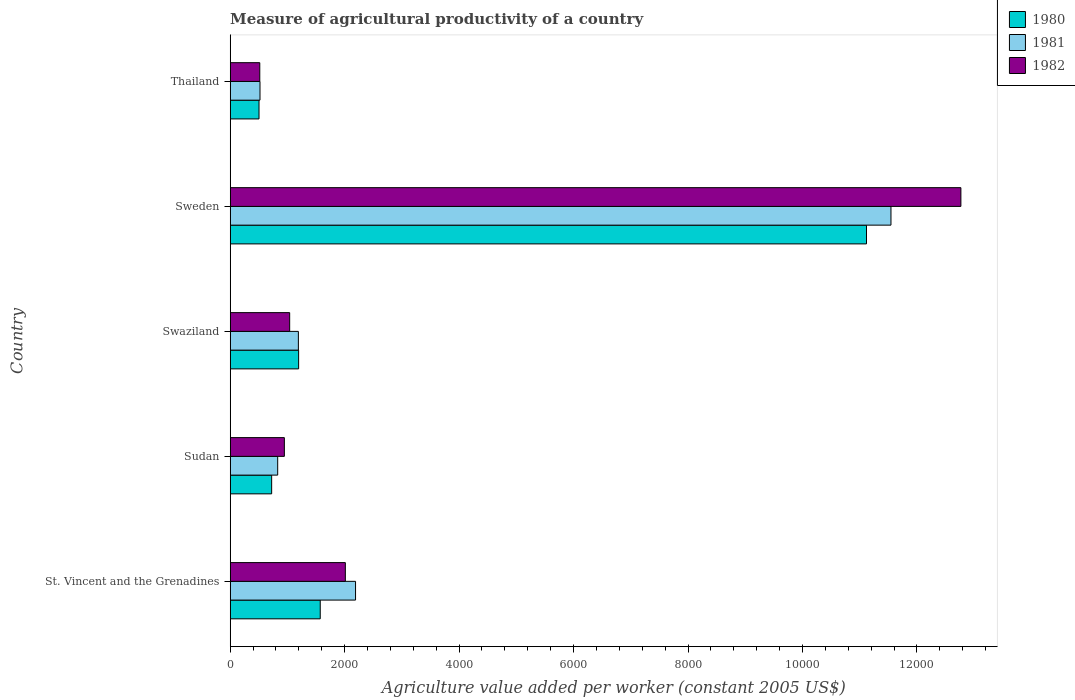How many different coloured bars are there?
Make the answer very short. 3. How many groups of bars are there?
Give a very brief answer. 5. How many bars are there on the 2nd tick from the bottom?
Keep it short and to the point. 3. What is the label of the 1st group of bars from the top?
Provide a succinct answer. Thailand. What is the measure of agricultural productivity in 1982 in Sweden?
Offer a very short reply. 1.28e+04. Across all countries, what is the maximum measure of agricultural productivity in 1980?
Provide a succinct answer. 1.11e+04. Across all countries, what is the minimum measure of agricultural productivity in 1981?
Ensure brevity in your answer.  521.09. In which country was the measure of agricultural productivity in 1981 maximum?
Keep it short and to the point. Sweden. In which country was the measure of agricultural productivity in 1982 minimum?
Your response must be concise. Thailand. What is the total measure of agricultural productivity in 1981 in the graph?
Make the answer very short. 1.63e+04. What is the difference between the measure of agricultural productivity in 1980 in St. Vincent and the Grenadines and that in Sweden?
Ensure brevity in your answer.  -9545.66. What is the difference between the measure of agricultural productivity in 1981 in Sweden and the measure of agricultural productivity in 1982 in Swaziland?
Keep it short and to the point. 1.05e+04. What is the average measure of agricultural productivity in 1981 per country?
Make the answer very short. 3255.98. What is the difference between the measure of agricultural productivity in 1980 and measure of agricultural productivity in 1981 in Thailand?
Make the answer very short. -17.34. What is the ratio of the measure of agricultural productivity in 1982 in Sweden to that in Thailand?
Ensure brevity in your answer.  24.69. Is the measure of agricultural productivity in 1980 in St. Vincent and the Grenadines less than that in Thailand?
Provide a short and direct response. No. What is the difference between the highest and the second highest measure of agricultural productivity in 1982?
Your answer should be compact. 1.08e+04. What is the difference between the highest and the lowest measure of agricultural productivity in 1980?
Your answer should be very brief. 1.06e+04. What does the 1st bar from the top in Swaziland represents?
Provide a short and direct response. 1982. What does the 2nd bar from the bottom in Thailand represents?
Make the answer very short. 1981. How many bars are there?
Offer a very short reply. 15. How many countries are there in the graph?
Provide a short and direct response. 5. Are the values on the major ticks of X-axis written in scientific E-notation?
Offer a terse response. No. Does the graph contain any zero values?
Ensure brevity in your answer.  No. What is the title of the graph?
Provide a short and direct response. Measure of agricultural productivity of a country. What is the label or title of the X-axis?
Provide a succinct answer. Agriculture value added per worker (constant 2005 US$). What is the label or title of the Y-axis?
Provide a succinct answer. Country. What is the Agriculture value added per worker (constant 2005 US$) in 1980 in St. Vincent and the Grenadines?
Your answer should be compact. 1573.39. What is the Agriculture value added per worker (constant 2005 US$) in 1981 in St. Vincent and the Grenadines?
Keep it short and to the point. 2190.63. What is the Agriculture value added per worker (constant 2005 US$) in 1982 in St. Vincent and the Grenadines?
Make the answer very short. 2012.15. What is the Agriculture value added per worker (constant 2005 US$) in 1980 in Sudan?
Keep it short and to the point. 724.57. What is the Agriculture value added per worker (constant 2005 US$) of 1981 in Sudan?
Offer a terse response. 829.99. What is the Agriculture value added per worker (constant 2005 US$) in 1982 in Sudan?
Make the answer very short. 946.58. What is the Agriculture value added per worker (constant 2005 US$) of 1980 in Swaziland?
Keep it short and to the point. 1196. What is the Agriculture value added per worker (constant 2005 US$) in 1981 in Swaziland?
Your answer should be very brief. 1191.63. What is the Agriculture value added per worker (constant 2005 US$) of 1982 in Swaziland?
Your response must be concise. 1039.39. What is the Agriculture value added per worker (constant 2005 US$) in 1980 in Sweden?
Your response must be concise. 1.11e+04. What is the Agriculture value added per worker (constant 2005 US$) of 1981 in Sweden?
Provide a succinct answer. 1.15e+04. What is the Agriculture value added per worker (constant 2005 US$) in 1982 in Sweden?
Offer a terse response. 1.28e+04. What is the Agriculture value added per worker (constant 2005 US$) of 1980 in Thailand?
Offer a terse response. 503.75. What is the Agriculture value added per worker (constant 2005 US$) of 1981 in Thailand?
Ensure brevity in your answer.  521.09. What is the Agriculture value added per worker (constant 2005 US$) in 1982 in Thailand?
Provide a short and direct response. 517.06. Across all countries, what is the maximum Agriculture value added per worker (constant 2005 US$) in 1980?
Your response must be concise. 1.11e+04. Across all countries, what is the maximum Agriculture value added per worker (constant 2005 US$) of 1981?
Your answer should be compact. 1.15e+04. Across all countries, what is the maximum Agriculture value added per worker (constant 2005 US$) in 1982?
Give a very brief answer. 1.28e+04. Across all countries, what is the minimum Agriculture value added per worker (constant 2005 US$) of 1980?
Offer a terse response. 503.75. Across all countries, what is the minimum Agriculture value added per worker (constant 2005 US$) of 1981?
Give a very brief answer. 521.09. Across all countries, what is the minimum Agriculture value added per worker (constant 2005 US$) in 1982?
Provide a succinct answer. 517.06. What is the total Agriculture value added per worker (constant 2005 US$) in 1980 in the graph?
Ensure brevity in your answer.  1.51e+04. What is the total Agriculture value added per worker (constant 2005 US$) of 1981 in the graph?
Ensure brevity in your answer.  1.63e+04. What is the total Agriculture value added per worker (constant 2005 US$) in 1982 in the graph?
Provide a short and direct response. 1.73e+04. What is the difference between the Agriculture value added per worker (constant 2005 US$) in 1980 in St. Vincent and the Grenadines and that in Sudan?
Your answer should be compact. 848.82. What is the difference between the Agriculture value added per worker (constant 2005 US$) of 1981 in St. Vincent and the Grenadines and that in Sudan?
Ensure brevity in your answer.  1360.64. What is the difference between the Agriculture value added per worker (constant 2005 US$) in 1982 in St. Vincent and the Grenadines and that in Sudan?
Give a very brief answer. 1065.58. What is the difference between the Agriculture value added per worker (constant 2005 US$) in 1980 in St. Vincent and the Grenadines and that in Swaziland?
Provide a succinct answer. 377.39. What is the difference between the Agriculture value added per worker (constant 2005 US$) in 1981 in St. Vincent and the Grenadines and that in Swaziland?
Your response must be concise. 999. What is the difference between the Agriculture value added per worker (constant 2005 US$) in 1982 in St. Vincent and the Grenadines and that in Swaziland?
Ensure brevity in your answer.  972.77. What is the difference between the Agriculture value added per worker (constant 2005 US$) in 1980 in St. Vincent and the Grenadines and that in Sweden?
Offer a terse response. -9545.66. What is the difference between the Agriculture value added per worker (constant 2005 US$) of 1981 in St. Vincent and the Grenadines and that in Sweden?
Offer a very short reply. -9355.93. What is the difference between the Agriculture value added per worker (constant 2005 US$) in 1982 in St. Vincent and the Grenadines and that in Sweden?
Keep it short and to the point. -1.08e+04. What is the difference between the Agriculture value added per worker (constant 2005 US$) of 1980 in St. Vincent and the Grenadines and that in Thailand?
Your answer should be compact. 1069.64. What is the difference between the Agriculture value added per worker (constant 2005 US$) of 1981 in St. Vincent and the Grenadines and that in Thailand?
Ensure brevity in your answer.  1669.53. What is the difference between the Agriculture value added per worker (constant 2005 US$) in 1982 in St. Vincent and the Grenadines and that in Thailand?
Provide a short and direct response. 1495.1. What is the difference between the Agriculture value added per worker (constant 2005 US$) of 1980 in Sudan and that in Swaziland?
Keep it short and to the point. -471.43. What is the difference between the Agriculture value added per worker (constant 2005 US$) in 1981 in Sudan and that in Swaziland?
Your response must be concise. -361.64. What is the difference between the Agriculture value added per worker (constant 2005 US$) in 1982 in Sudan and that in Swaziland?
Your response must be concise. -92.81. What is the difference between the Agriculture value added per worker (constant 2005 US$) of 1980 in Sudan and that in Sweden?
Keep it short and to the point. -1.04e+04. What is the difference between the Agriculture value added per worker (constant 2005 US$) of 1981 in Sudan and that in Sweden?
Make the answer very short. -1.07e+04. What is the difference between the Agriculture value added per worker (constant 2005 US$) in 1982 in Sudan and that in Sweden?
Your answer should be very brief. -1.18e+04. What is the difference between the Agriculture value added per worker (constant 2005 US$) of 1980 in Sudan and that in Thailand?
Your answer should be compact. 220.82. What is the difference between the Agriculture value added per worker (constant 2005 US$) in 1981 in Sudan and that in Thailand?
Provide a succinct answer. 308.9. What is the difference between the Agriculture value added per worker (constant 2005 US$) in 1982 in Sudan and that in Thailand?
Offer a terse response. 429.52. What is the difference between the Agriculture value added per worker (constant 2005 US$) of 1980 in Swaziland and that in Sweden?
Your answer should be very brief. -9923.05. What is the difference between the Agriculture value added per worker (constant 2005 US$) in 1981 in Swaziland and that in Sweden?
Ensure brevity in your answer.  -1.04e+04. What is the difference between the Agriculture value added per worker (constant 2005 US$) in 1982 in Swaziland and that in Sweden?
Your answer should be compact. -1.17e+04. What is the difference between the Agriculture value added per worker (constant 2005 US$) of 1980 in Swaziland and that in Thailand?
Ensure brevity in your answer.  692.25. What is the difference between the Agriculture value added per worker (constant 2005 US$) in 1981 in Swaziland and that in Thailand?
Provide a short and direct response. 670.54. What is the difference between the Agriculture value added per worker (constant 2005 US$) of 1982 in Swaziland and that in Thailand?
Provide a short and direct response. 522.33. What is the difference between the Agriculture value added per worker (constant 2005 US$) of 1980 in Sweden and that in Thailand?
Make the answer very short. 1.06e+04. What is the difference between the Agriculture value added per worker (constant 2005 US$) of 1981 in Sweden and that in Thailand?
Keep it short and to the point. 1.10e+04. What is the difference between the Agriculture value added per worker (constant 2005 US$) of 1982 in Sweden and that in Thailand?
Your answer should be very brief. 1.23e+04. What is the difference between the Agriculture value added per worker (constant 2005 US$) of 1980 in St. Vincent and the Grenadines and the Agriculture value added per worker (constant 2005 US$) of 1981 in Sudan?
Offer a very short reply. 743.4. What is the difference between the Agriculture value added per worker (constant 2005 US$) in 1980 in St. Vincent and the Grenadines and the Agriculture value added per worker (constant 2005 US$) in 1982 in Sudan?
Provide a succinct answer. 626.81. What is the difference between the Agriculture value added per worker (constant 2005 US$) of 1981 in St. Vincent and the Grenadines and the Agriculture value added per worker (constant 2005 US$) of 1982 in Sudan?
Provide a short and direct response. 1244.05. What is the difference between the Agriculture value added per worker (constant 2005 US$) in 1980 in St. Vincent and the Grenadines and the Agriculture value added per worker (constant 2005 US$) in 1981 in Swaziland?
Give a very brief answer. 381.76. What is the difference between the Agriculture value added per worker (constant 2005 US$) of 1980 in St. Vincent and the Grenadines and the Agriculture value added per worker (constant 2005 US$) of 1982 in Swaziland?
Your answer should be compact. 534. What is the difference between the Agriculture value added per worker (constant 2005 US$) of 1981 in St. Vincent and the Grenadines and the Agriculture value added per worker (constant 2005 US$) of 1982 in Swaziland?
Your answer should be compact. 1151.24. What is the difference between the Agriculture value added per worker (constant 2005 US$) of 1980 in St. Vincent and the Grenadines and the Agriculture value added per worker (constant 2005 US$) of 1981 in Sweden?
Give a very brief answer. -9973.17. What is the difference between the Agriculture value added per worker (constant 2005 US$) of 1980 in St. Vincent and the Grenadines and the Agriculture value added per worker (constant 2005 US$) of 1982 in Sweden?
Ensure brevity in your answer.  -1.12e+04. What is the difference between the Agriculture value added per worker (constant 2005 US$) in 1981 in St. Vincent and the Grenadines and the Agriculture value added per worker (constant 2005 US$) in 1982 in Sweden?
Your answer should be compact. -1.06e+04. What is the difference between the Agriculture value added per worker (constant 2005 US$) of 1980 in St. Vincent and the Grenadines and the Agriculture value added per worker (constant 2005 US$) of 1981 in Thailand?
Ensure brevity in your answer.  1052.3. What is the difference between the Agriculture value added per worker (constant 2005 US$) of 1980 in St. Vincent and the Grenadines and the Agriculture value added per worker (constant 2005 US$) of 1982 in Thailand?
Provide a short and direct response. 1056.33. What is the difference between the Agriculture value added per worker (constant 2005 US$) of 1981 in St. Vincent and the Grenadines and the Agriculture value added per worker (constant 2005 US$) of 1982 in Thailand?
Your answer should be very brief. 1673.57. What is the difference between the Agriculture value added per worker (constant 2005 US$) in 1980 in Sudan and the Agriculture value added per worker (constant 2005 US$) in 1981 in Swaziland?
Offer a very short reply. -467.06. What is the difference between the Agriculture value added per worker (constant 2005 US$) in 1980 in Sudan and the Agriculture value added per worker (constant 2005 US$) in 1982 in Swaziland?
Your answer should be very brief. -314.82. What is the difference between the Agriculture value added per worker (constant 2005 US$) of 1981 in Sudan and the Agriculture value added per worker (constant 2005 US$) of 1982 in Swaziland?
Your answer should be very brief. -209.4. What is the difference between the Agriculture value added per worker (constant 2005 US$) in 1980 in Sudan and the Agriculture value added per worker (constant 2005 US$) in 1981 in Sweden?
Ensure brevity in your answer.  -1.08e+04. What is the difference between the Agriculture value added per worker (constant 2005 US$) of 1980 in Sudan and the Agriculture value added per worker (constant 2005 US$) of 1982 in Sweden?
Provide a succinct answer. -1.20e+04. What is the difference between the Agriculture value added per worker (constant 2005 US$) in 1981 in Sudan and the Agriculture value added per worker (constant 2005 US$) in 1982 in Sweden?
Ensure brevity in your answer.  -1.19e+04. What is the difference between the Agriculture value added per worker (constant 2005 US$) in 1980 in Sudan and the Agriculture value added per worker (constant 2005 US$) in 1981 in Thailand?
Make the answer very short. 203.48. What is the difference between the Agriculture value added per worker (constant 2005 US$) in 1980 in Sudan and the Agriculture value added per worker (constant 2005 US$) in 1982 in Thailand?
Offer a very short reply. 207.51. What is the difference between the Agriculture value added per worker (constant 2005 US$) in 1981 in Sudan and the Agriculture value added per worker (constant 2005 US$) in 1982 in Thailand?
Provide a succinct answer. 312.93. What is the difference between the Agriculture value added per worker (constant 2005 US$) in 1980 in Swaziland and the Agriculture value added per worker (constant 2005 US$) in 1981 in Sweden?
Offer a very short reply. -1.04e+04. What is the difference between the Agriculture value added per worker (constant 2005 US$) of 1980 in Swaziland and the Agriculture value added per worker (constant 2005 US$) of 1982 in Sweden?
Your answer should be very brief. -1.16e+04. What is the difference between the Agriculture value added per worker (constant 2005 US$) of 1981 in Swaziland and the Agriculture value added per worker (constant 2005 US$) of 1982 in Sweden?
Give a very brief answer. -1.16e+04. What is the difference between the Agriculture value added per worker (constant 2005 US$) of 1980 in Swaziland and the Agriculture value added per worker (constant 2005 US$) of 1981 in Thailand?
Your response must be concise. 674.91. What is the difference between the Agriculture value added per worker (constant 2005 US$) in 1980 in Swaziland and the Agriculture value added per worker (constant 2005 US$) in 1982 in Thailand?
Provide a short and direct response. 678.94. What is the difference between the Agriculture value added per worker (constant 2005 US$) of 1981 in Swaziland and the Agriculture value added per worker (constant 2005 US$) of 1982 in Thailand?
Your answer should be compact. 674.57. What is the difference between the Agriculture value added per worker (constant 2005 US$) of 1980 in Sweden and the Agriculture value added per worker (constant 2005 US$) of 1981 in Thailand?
Offer a terse response. 1.06e+04. What is the difference between the Agriculture value added per worker (constant 2005 US$) in 1980 in Sweden and the Agriculture value added per worker (constant 2005 US$) in 1982 in Thailand?
Offer a very short reply. 1.06e+04. What is the difference between the Agriculture value added per worker (constant 2005 US$) of 1981 in Sweden and the Agriculture value added per worker (constant 2005 US$) of 1982 in Thailand?
Your response must be concise. 1.10e+04. What is the average Agriculture value added per worker (constant 2005 US$) in 1980 per country?
Make the answer very short. 3023.35. What is the average Agriculture value added per worker (constant 2005 US$) in 1981 per country?
Offer a very short reply. 3255.98. What is the average Agriculture value added per worker (constant 2005 US$) of 1982 per country?
Make the answer very short. 3456.73. What is the difference between the Agriculture value added per worker (constant 2005 US$) of 1980 and Agriculture value added per worker (constant 2005 US$) of 1981 in St. Vincent and the Grenadines?
Provide a succinct answer. -617.23. What is the difference between the Agriculture value added per worker (constant 2005 US$) of 1980 and Agriculture value added per worker (constant 2005 US$) of 1982 in St. Vincent and the Grenadines?
Ensure brevity in your answer.  -438.76. What is the difference between the Agriculture value added per worker (constant 2005 US$) in 1981 and Agriculture value added per worker (constant 2005 US$) in 1982 in St. Vincent and the Grenadines?
Provide a short and direct response. 178.47. What is the difference between the Agriculture value added per worker (constant 2005 US$) in 1980 and Agriculture value added per worker (constant 2005 US$) in 1981 in Sudan?
Offer a very short reply. -105.42. What is the difference between the Agriculture value added per worker (constant 2005 US$) in 1980 and Agriculture value added per worker (constant 2005 US$) in 1982 in Sudan?
Make the answer very short. -222.01. What is the difference between the Agriculture value added per worker (constant 2005 US$) in 1981 and Agriculture value added per worker (constant 2005 US$) in 1982 in Sudan?
Your answer should be compact. -116.59. What is the difference between the Agriculture value added per worker (constant 2005 US$) in 1980 and Agriculture value added per worker (constant 2005 US$) in 1981 in Swaziland?
Your answer should be very brief. 4.37. What is the difference between the Agriculture value added per worker (constant 2005 US$) of 1980 and Agriculture value added per worker (constant 2005 US$) of 1982 in Swaziland?
Provide a short and direct response. 156.61. What is the difference between the Agriculture value added per worker (constant 2005 US$) of 1981 and Agriculture value added per worker (constant 2005 US$) of 1982 in Swaziland?
Keep it short and to the point. 152.24. What is the difference between the Agriculture value added per worker (constant 2005 US$) of 1980 and Agriculture value added per worker (constant 2005 US$) of 1981 in Sweden?
Offer a very short reply. -427.51. What is the difference between the Agriculture value added per worker (constant 2005 US$) of 1980 and Agriculture value added per worker (constant 2005 US$) of 1982 in Sweden?
Your answer should be very brief. -1649.43. What is the difference between the Agriculture value added per worker (constant 2005 US$) of 1981 and Agriculture value added per worker (constant 2005 US$) of 1982 in Sweden?
Your response must be concise. -1221.92. What is the difference between the Agriculture value added per worker (constant 2005 US$) of 1980 and Agriculture value added per worker (constant 2005 US$) of 1981 in Thailand?
Make the answer very short. -17.34. What is the difference between the Agriculture value added per worker (constant 2005 US$) in 1980 and Agriculture value added per worker (constant 2005 US$) in 1982 in Thailand?
Keep it short and to the point. -13.31. What is the difference between the Agriculture value added per worker (constant 2005 US$) of 1981 and Agriculture value added per worker (constant 2005 US$) of 1982 in Thailand?
Keep it short and to the point. 4.03. What is the ratio of the Agriculture value added per worker (constant 2005 US$) in 1980 in St. Vincent and the Grenadines to that in Sudan?
Ensure brevity in your answer.  2.17. What is the ratio of the Agriculture value added per worker (constant 2005 US$) in 1981 in St. Vincent and the Grenadines to that in Sudan?
Offer a very short reply. 2.64. What is the ratio of the Agriculture value added per worker (constant 2005 US$) of 1982 in St. Vincent and the Grenadines to that in Sudan?
Provide a succinct answer. 2.13. What is the ratio of the Agriculture value added per worker (constant 2005 US$) of 1980 in St. Vincent and the Grenadines to that in Swaziland?
Your response must be concise. 1.32. What is the ratio of the Agriculture value added per worker (constant 2005 US$) of 1981 in St. Vincent and the Grenadines to that in Swaziland?
Keep it short and to the point. 1.84. What is the ratio of the Agriculture value added per worker (constant 2005 US$) in 1982 in St. Vincent and the Grenadines to that in Swaziland?
Keep it short and to the point. 1.94. What is the ratio of the Agriculture value added per worker (constant 2005 US$) in 1980 in St. Vincent and the Grenadines to that in Sweden?
Give a very brief answer. 0.14. What is the ratio of the Agriculture value added per worker (constant 2005 US$) of 1981 in St. Vincent and the Grenadines to that in Sweden?
Your response must be concise. 0.19. What is the ratio of the Agriculture value added per worker (constant 2005 US$) in 1982 in St. Vincent and the Grenadines to that in Sweden?
Your response must be concise. 0.16. What is the ratio of the Agriculture value added per worker (constant 2005 US$) in 1980 in St. Vincent and the Grenadines to that in Thailand?
Provide a succinct answer. 3.12. What is the ratio of the Agriculture value added per worker (constant 2005 US$) of 1981 in St. Vincent and the Grenadines to that in Thailand?
Provide a short and direct response. 4.2. What is the ratio of the Agriculture value added per worker (constant 2005 US$) of 1982 in St. Vincent and the Grenadines to that in Thailand?
Your answer should be very brief. 3.89. What is the ratio of the Agriculture value added per worker (constant 2005 US$) of 1980 in Sudan to that in Swaziland?
Your answer should be very brief. 0.61. What is the ratio of the Agriculture value added per worker (constant 2005 US$) in 1981 in Sudan to that in Swaziland?
Keep it short and to the point. 0.7. What is the ratio of the Agriculture value added per worker (constant 2005 US$) of 1982 in Sudan to that in Swaziland?
Give a very brief answer. 0.91. What is the ratio of the Agriculture value added per worker (constant 2005 US$) in 1980 in Sudan to that in Sweden?
Provide a succinct answer. 0.07. What is the ratio of the Agriculture value added per worker (constant 2005 US$) of 1981 in Sudan to that in Sweden?
Your answer should be very brief. 0.07. What is the ratio of the Agriculture value added per worker (constant 2005 US$) in 1982 in Sudan to that in Sweden?
Your answer should be very brief. 0.07. What is the ratio of the Agriculture value added per worker (constant 2005 US$) in 1980 in Sudan to that in Thailand?
Provide a short and direct response. 1.44. What is the ratio of the Agriculture value added per worker (constant 2005 US$) of 1981 in Sudan to that in Thailand?
Offer a terse response. 1.59. What is the ratio of the Agriculture value added per worker (constant 2005 US$) in 1982 in Sudan to that in Thailand?
Give a very brief answer. 1.83. What is the ratio of the Agriculture value added per worker (constant 2005 US$) in 1980 in Swaziland to that in Sweden?
Provide a succinct answer. 0.11. What is the ratio of the Agriculture value added per worker (constant 2005 US$) of 1981 in Swaziland to that in Sweden?
Provide a succinct answer. 0.1. What is the ratio of the Agriculture value added per worker (constant 2005 US$) of 1982 in Swaziland to that in Sweden?
Provide a short and direct response. 0.08. What is the ratio of the Agriculture value added per worker (constant 2005 US$) in 1980 in Swaziland to that in Thailand?
Offer a terse response. 2.37. What is the ratio of the Agriculture value added per worker (constant 2005 US$) of 1981 in Swaziland to that in Thailand?
Provide a short and direct response. 2.29. What is the ratio of the Agriculture value added per worker (constant 2005 US$) in 1982 in Swaziland to that in Thailand?
Ensure brevity in your answer.  2.01. What is the ratio of the Agriculture value added per worker (constant 2005 US$) in 1980 in Sweden to that in Thailand?
Your answer should be very brief. 22.07. What is the ratio of the Agriculture value added per worker (constant 2005 US$) in 1981 in Sweden to that in Thailand?
Ensure brevity in your answer.  22.16. What is the ratio of the Agriculture value added per worker (constant 2005 US$) of 1982 in Sweden to that in Thailand?
Provide a succinct answer. 24.69. What is the difference between the highest and the second highest Agriculture value added per worker (constant 2005 US$) of 1980?
Offer a very short reply. 9545.66. What is the difference between the highest and the second highest Agriculture value added per worker (constant 2005 US$) of 1981?
Ensure brevity in your answer.  9355.93. What is the difference between the highest and the second highest Agriculture value added per worker (constant 2005 US$) in 1982?
Your answer should be very brief. 1.08e+04. What is the difference between the highest and the lowest Agriculture value added per worker (constant 2005 US$) of 1980?
Your answer should be compact. 1.06e+04. What is the difference between the highest and the lowest Agriculture value added per worker (constant 2005 US$) of 1981?
Provide a succinct answer. 1.10e+04. What is the difference between the highest and the lowest Agriculture value added per worker (constant 2005 US$) of 1982?
Ensure brevity in your answer.  1.23e+04. 